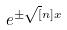<formula> <loc_0><loc_0><loc_500><loc_500>e ^ { \pm \sqrt { [ } n ] { x } }</formula> 